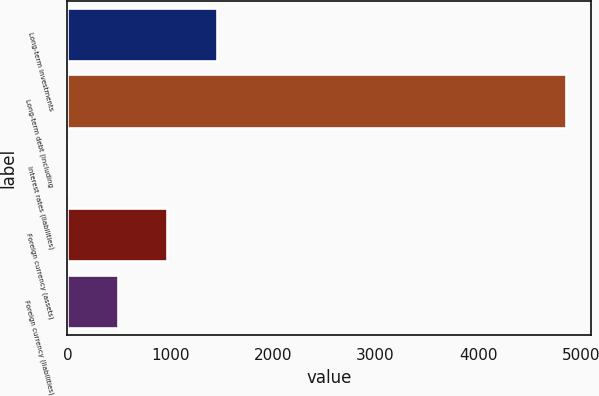Convert chart. <chart><loc_0><loc_0><loc_500><loc_500><bar_chart><fcel>Long-term investments<fcel>Long-term debt (including<fcel>Interest rates (liabilities)<fcel>Foreign currency (assets)<fcel>Foreign currency (liabilities)<nl><fcel>1459.3<fcel>4858.5<fcel>2.5<fcel>973.7<fcel>488.1<nl></chart> 